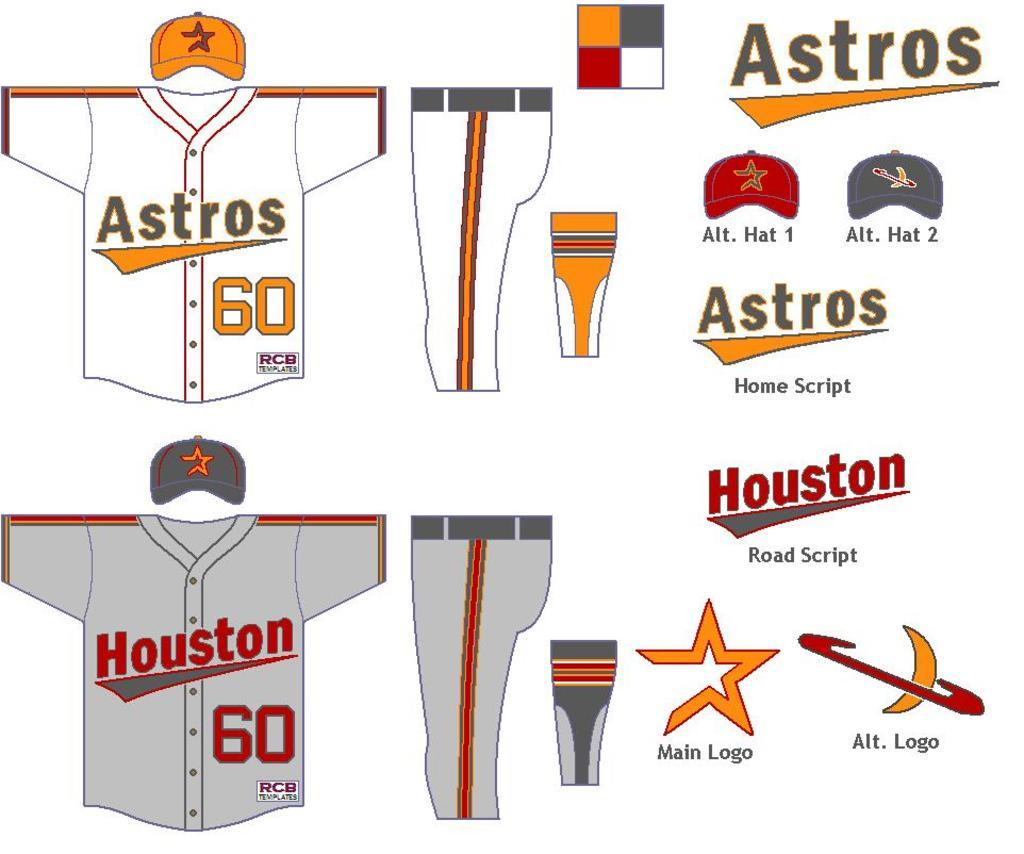<image>
Provide a brief description of the given image. A poster details various aspects of the Houston Astros uniform. 